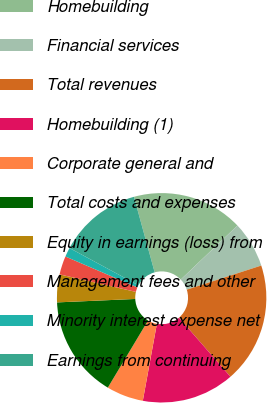Convert chart to OTSL. <chart><loc_0><loc_0><loc_500><loc_500><pie_chart><fcel>Homebuilding<fcel>Financial services<fcel>Total revenues<fcel>Homebuilding (1)<fcel>Corporate general and<fcel>Total costs and expenses<fcel>Equity in earnings (loss) from<fcel>Management fees and other<fcel>Minority interest expense net<fcel>Earnings from continuing<nl><fcel>17.14%<fcel>7.14%<fcel>18.57%<fcel>14.29%<fcel>5.71%<fcel>15.71%<fcel>4.29%<fcel>2.86%<fcel>1.43%<fcel>12.86%<nl></chart> 